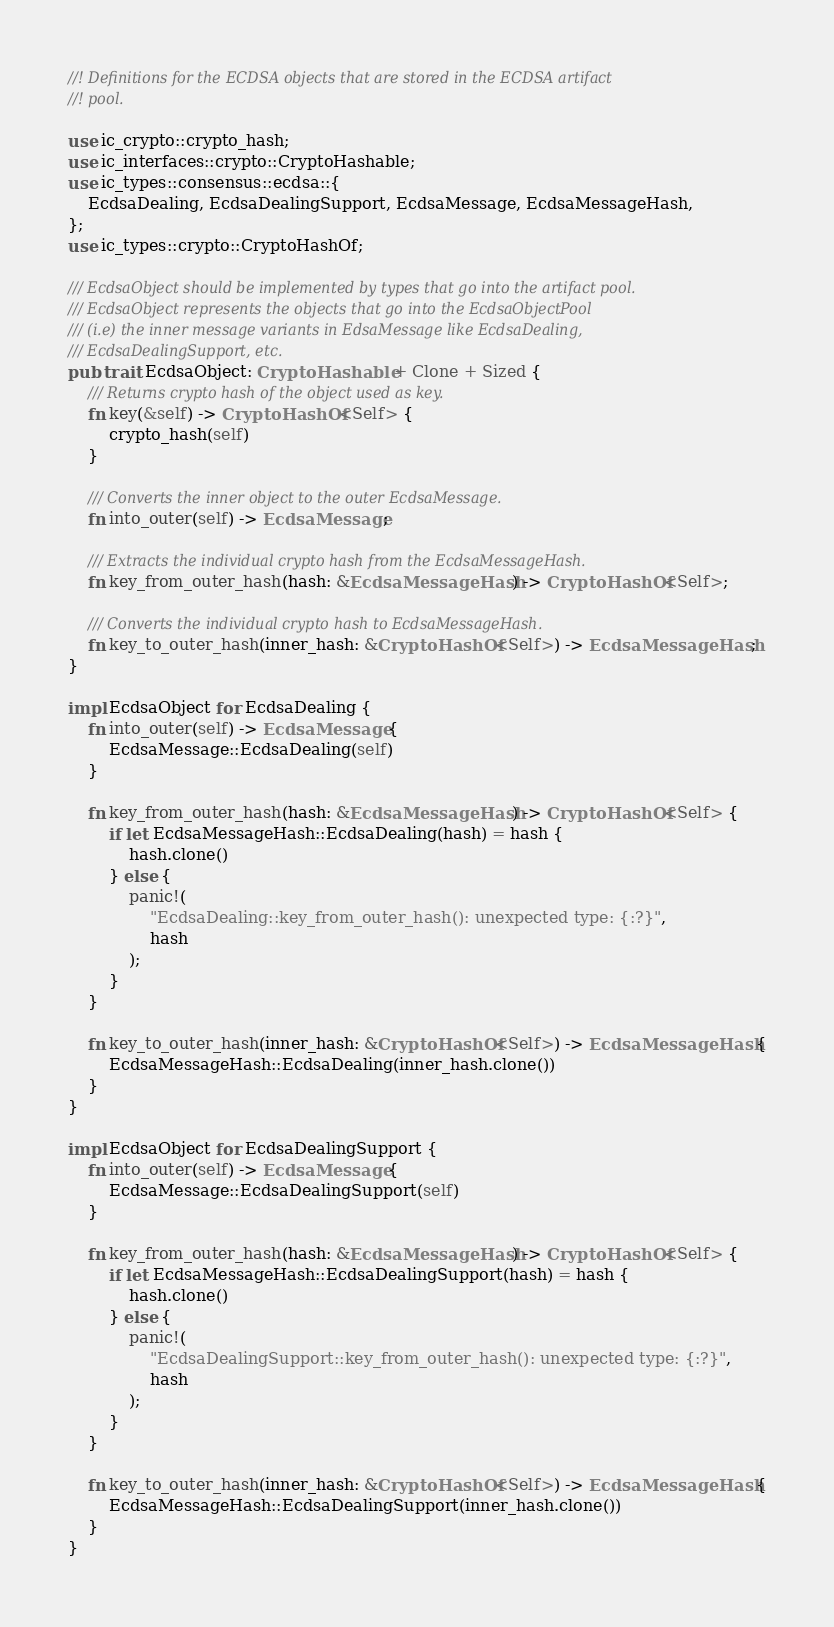<code> <loc_0><loc_0><loc_500><loc_500><_Rust_>//! Definitions for the ECDSA objects that are stored in the ECDSA artifact
//! pool.

use ic_crypto::crypto_hash;
use ic_interfaces::crypto::CryptoHashable;
use ic_types::consensus::ecdsa::{
    EcdsaDealing, EcdsaDealingSupport, EcdsaMessage, EcdsaMessageHash,
};
use ic_types::crypto::CryptoHashOf;

/// EcdsaObject should be implemented by types that go into the artifact pool.
/// EcdsaObject represents the objects that go into the EcdsaObjectPool
/// (i.e) the inner message variants in EdsaMessage like EcdsaDealing,
/// EcdsaDealingSupport, etc.
pub trait EcdsaObject: CryptoHashable + Clone + Sized {
    /// Returns crypto hash of the object used as key.
    fn key(&self) -> CryptoHashOf<Self> {
        crypto_hash(self)
    }

    /// Converts the inner object to the outer EcdsaMessage.
    fn into_outer(self) -> EcdsaMessage;

    /// Extracts the individual crypto hash from the EcdsaMessageHash.
    fn key_from_outer_hash(hash: &EcdsaMessageHash) -> CryptoHashOf<Self>;

    /// Converts the individual crypto hash to EcdsaMessageHash.
    fn key_to_outer_hash(inner_hash: &CryptoHashOf<Self>) -> EcdsaMessageHash;
}

impl EcdsaObject for EcdsaDealing {
    fn into_outer(self) -> EcdsaMessage {
        EcdsaMessage::EcdsaDealing(self)
    }

    fn key_from_outer_hash(hash: &EcdsaMessageHash) -> CryptoHashOf<Self> {
        if let EcdsaMessageHash::EcdsaDealing(hash) = hash {
            hash.clone()
        } else {
            panic!(
                "EcdsaDealing::key_from_outer_hash(): unexpected type: {:?}",
                hash
            );
        }
    }

    fn key_to_outer_hash(inner_hash: &CryptoHashOf<Self>) -> EcdsaMessageHash {
        EcdsaMessageHash::EcdsaDealing(inner_hash.clone())
    }
}

impl EcdsaObject for EcdsaDealingSupport {
    fn into_outer(self) -> EcdsaMessage {
        EcdsaMessage::EcdsaDealingSupport(self)
    }

    fn key_from_outer_hash(hash: &EcdsaMessageHash) -> CryptoHashOf<Self> {
        if let EcdsaMessageHash::EcdsaDealingSupport(hash) = hash {
            hash.clone()
        } else {
            panic!(
                "EcdsaDealingSupport::key_from_outer_hash(): unexpected type: {:?}",
                hash
            );
        }
    }

    fn key_to_outer_hash(inner_hash: &CryptoHashOf<Self>) -> EcdsaMessageHash {
        EcdsaMessageHash::EcdsaDealingSupport(inner_hash.clone())
    }
}
</code> 